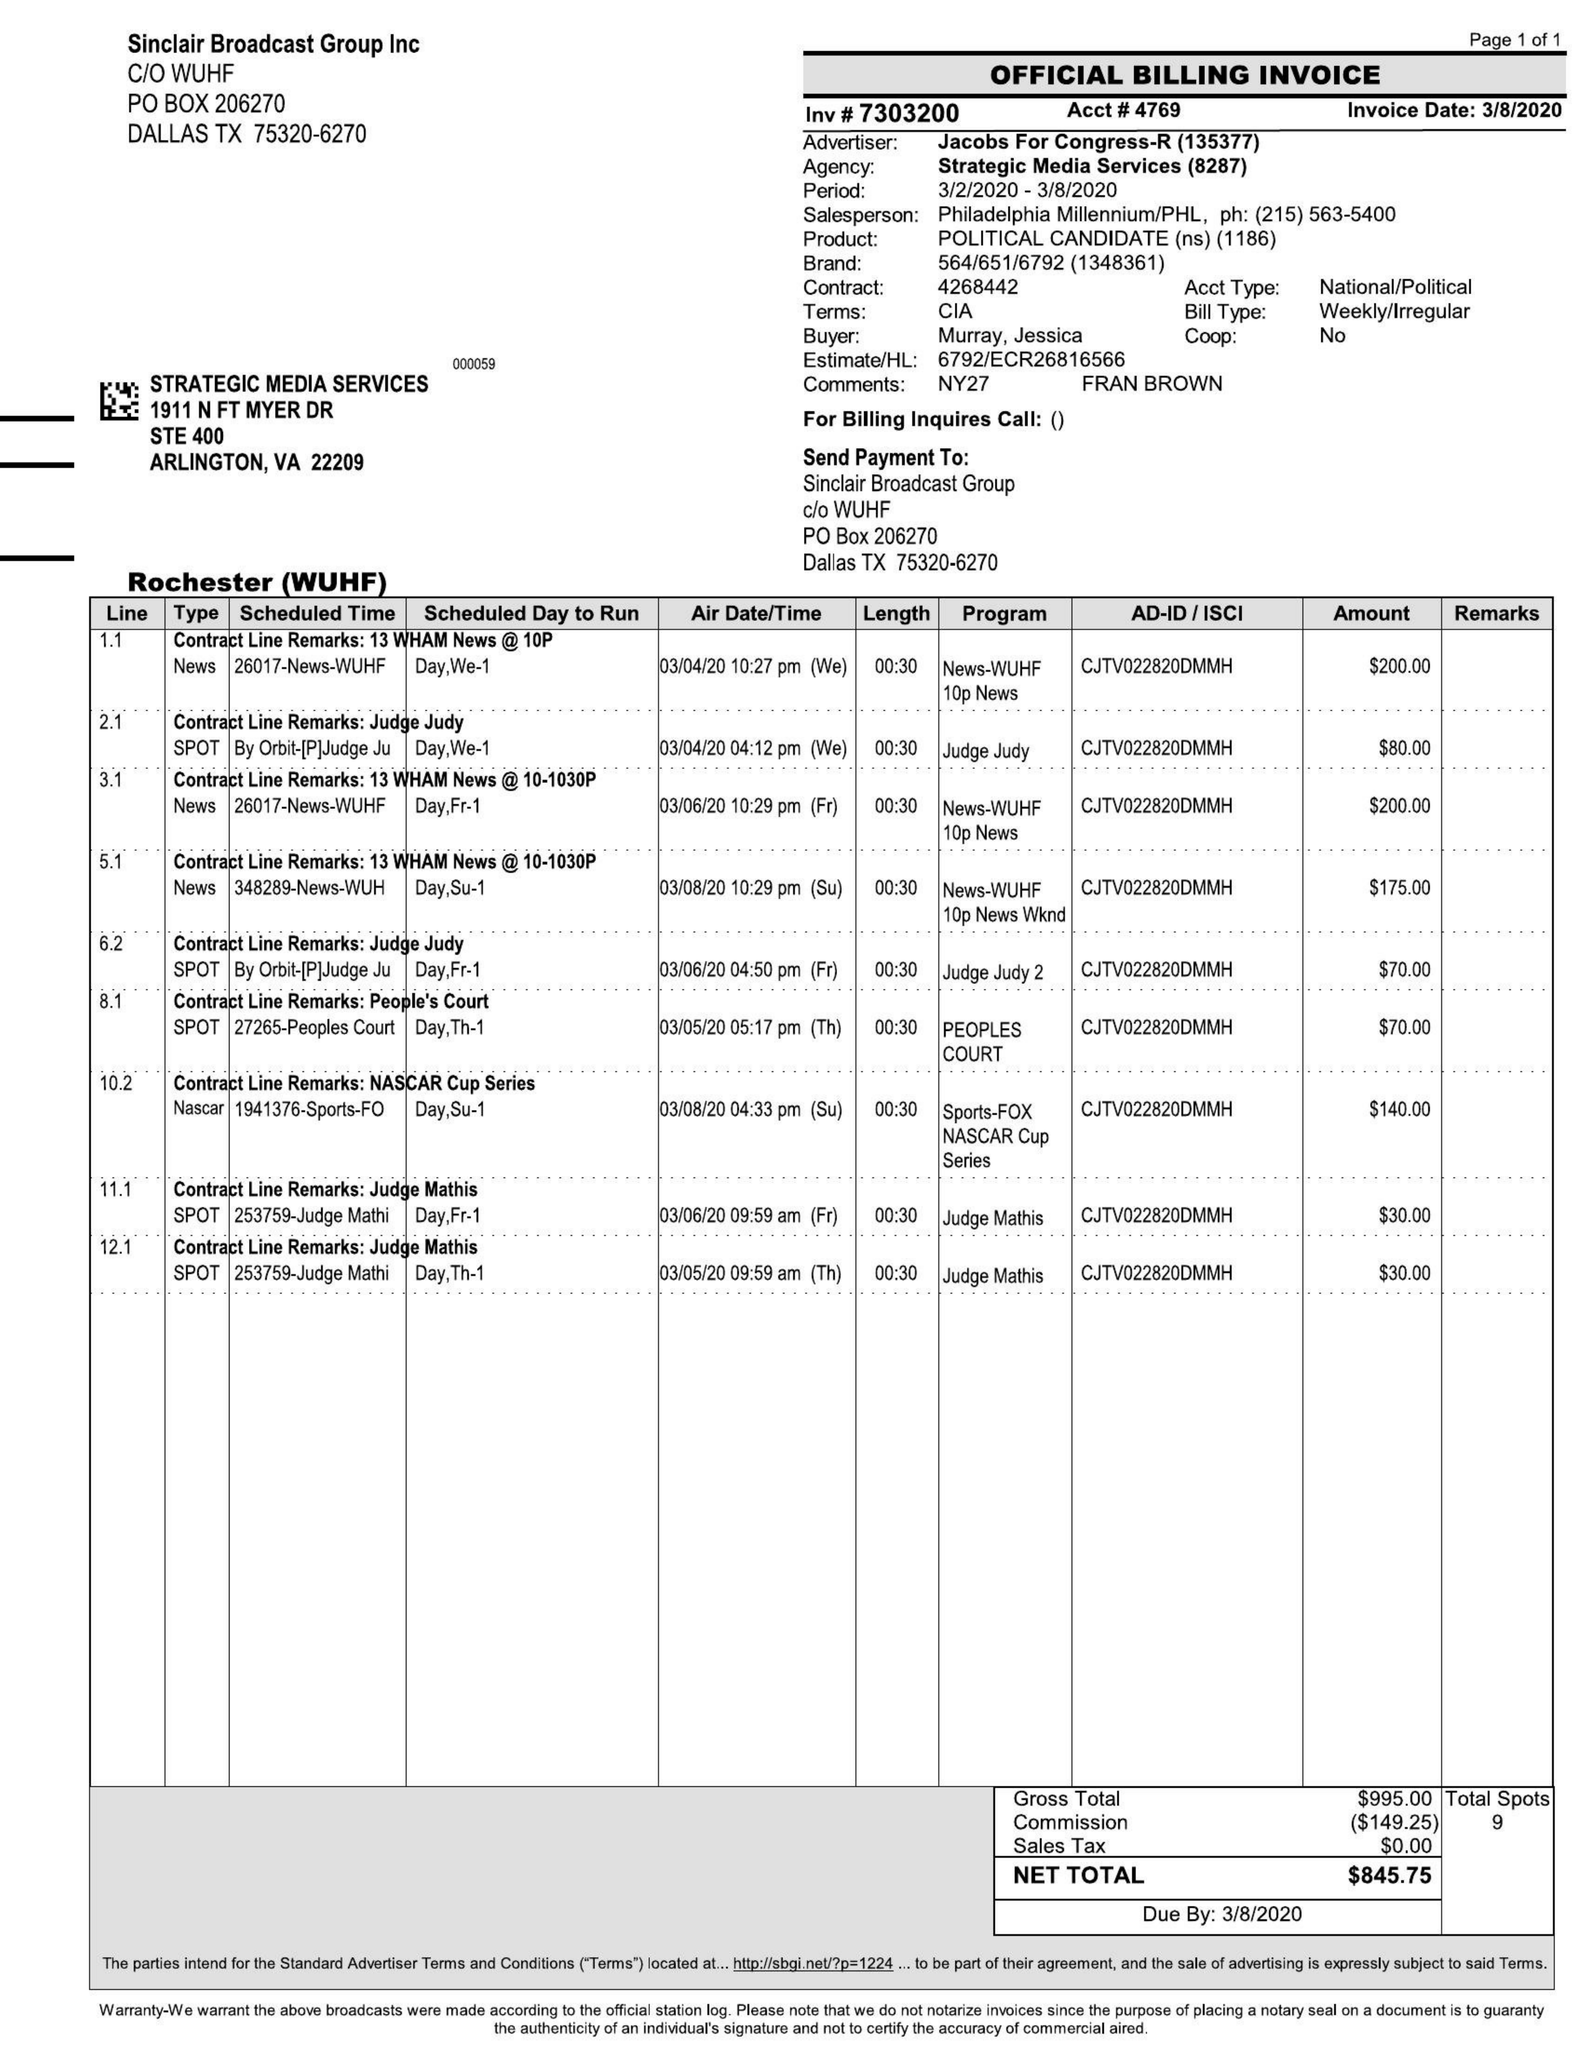What is the value for the gross_amount?
Answer the question using a single word or phrase. 995.00 